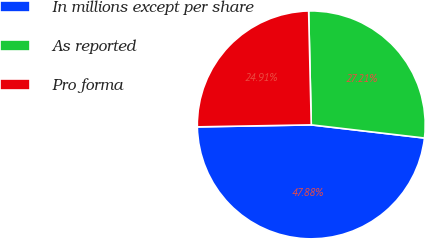<chart> <loc_0><loc_0><loc_500><loc_500><pie_chart><fcel>In millions except per share<fcel>As reported<fcel>Pro forma<nl><fcel>47.88%<fcel>27.21%<fcel>24.91%<nl></chart> 